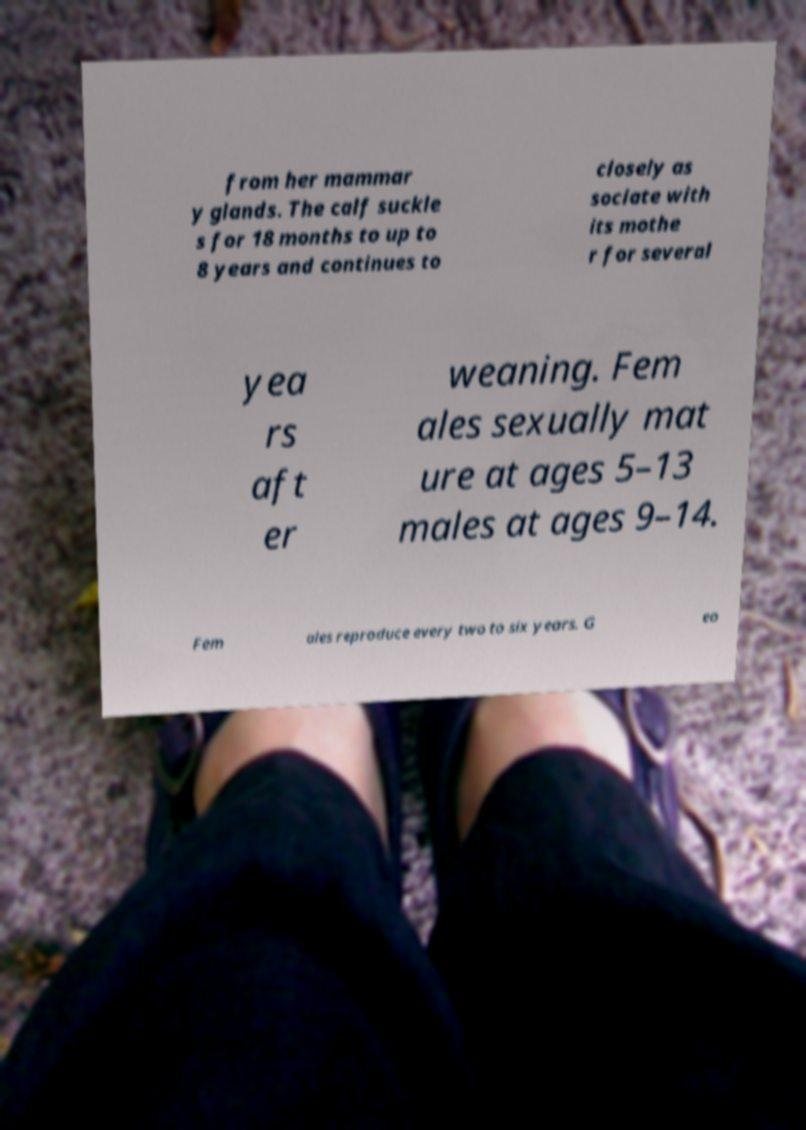Please read and relay the text visible in this image. What does it say? from her mammar y glands. The calf suckle s for 18 months to up to 8 years and continues to closely as sociate with its mothe r for several yea rs aft er weaning. Fem ales sexually mat ure at ages 5–13 males at ages 9–14. Fem ales reproduce every two to six years. G eo 